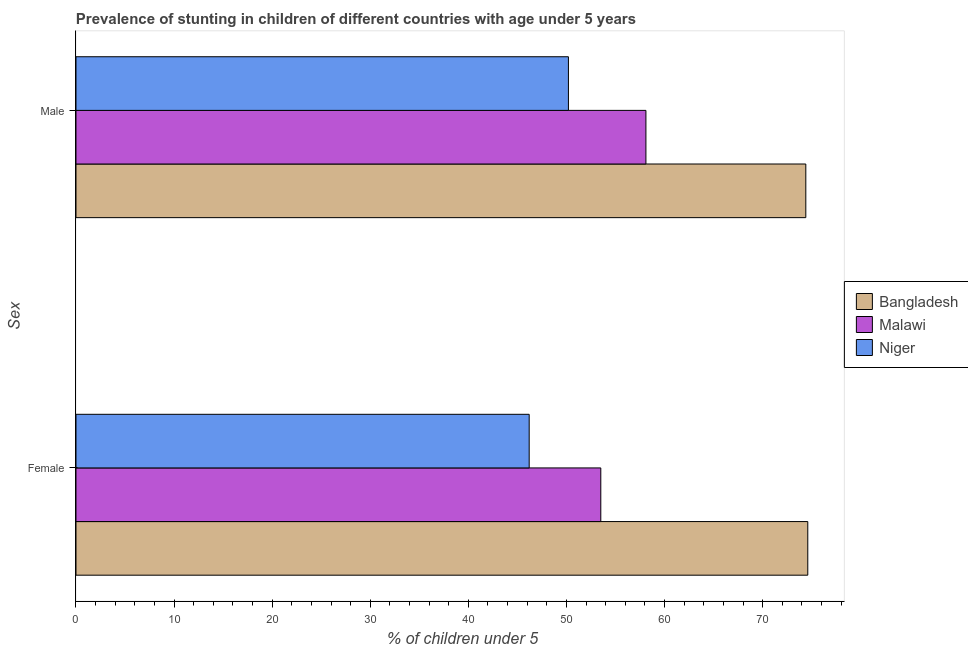How many groups of bars are there?
Provide a short and direct response. 2. Are the number of bars on each tick of the Y-axis equal?
Offer a very short reply. Yes. How many bars are there on the 1st tick from the top?
Make the answer very short. 3. What is the percentage of stunted male children in Malawi?
Ensure brevity in your answer.  58.1. Across all countries, what is the maximum percentage of stunted female children?
Give a very brief answer. 74.6. Across all countries, what is the minimum percentage of stunted male children?
Your answer should be very brief. 50.2. In which country was the percentage of stunted female children maximum?
Ensure brevity in your answer.  Bangladesh. In which country was the percentage of stunted male children minimum?
Provide a succinct answer. Niger. What is the total percentage of stunted female children in the graph?
Your response must be concise. 174.3. What is the difference between the percentage of stunted female children in Niger and that in Malawi?
Give a very brief answer. -7.3. What is the difference between the percentage of stunted male children in Malawi and the percentage of stunted female children in Bangladesh?
Your response must be concise. -16.5. What is the average percentage of stunted female children per country?
Your response must be concise. 58.1. What is the difference between the percentage of stunted female children and percentage of stunted male children in Malawi?
Your answer should be compact. -4.6. What is the ratio of the percentage of stunted female children in Malawi to that in Bangladesh?
Give a very brief answer. 0.72. In how many countries, is the percentage of stunted female children greater than the average percentage of stunted female children taken over all countries?
Keep it short and to the point. 1. What does the 1st bar from the top in Male represents?
Offer a very short reply. Niger. What does the 3rd bar from the bottom in Male represents?
Ensure brevity in your answer.  Niger. How many bars are there?
Make the answer very short. 6. Are all the bars in the graph horizontal?
Provide a succinct answer. Yes. How many countries are there in the graph?
Give a very brief answer. 3. What is the difference between two consecutive major ticks on the X-axis?
Your response must be concise. 10. Are the values on the major ticks of X-axis written in scientific E-notation?
Offer a terse response. No. Does the graph contain any zero values?
Offer a terse response. No. Does the graph contain grids?
Provide a short and direct response. No. Where does the legend appear in the graph?
Keep it short and to the point. Center right. How many legend labels are there?
Your response must be concise. 3. How are the legend labels stacked?
Keep it short and to the point. Vertical. What is the title of the graph?
Give a very brief answer. Prevalence of stunting in children of different countries with age under 5 years. What is the label or title of the X-axis?
Offer a terse response.  % of children under 5. What is the label or title of the Y-axis?
Ensure brevity in your answer.  Sex. What is the  % of children under 5 in Bangladesh in Female?
Offer a terse response. 74.6. What is the  % of children under 5 of Malawi in Female?
Make the answer very short. 53.5. What is the  % of children under 5 of Niger in Female?
Offer a very short reply. 46.2. What is the  % of children under 5 in Bangladesh in Male?
Your response must be concise. 74.4. What is the  % of children under 5 of Malawi in Male?
Keep it short and to the point. 58.1. What is the  % of children under 5 in Niger in Male?
Make the answer very short. 50.2. Across all Sex, what is the maximum  % of children under 5 in Bangladesh?
Make the answer very short. 74.6. Across all Sex, what is the maximum  % of children under 5 in Malawi?
Ensure brevity in your answer.  58.1. Across all Sex, what is the maximum  % of children under 5 in Niger?
Your answer should be compact. 50.2. Across all Sex, what is the minimum  % of children under 5 of Bangladesh?
Provide a short and direct response. 74.4. Across all Sex, what is the minimum  % of children under 5 of Malawi?
Your answer should be compact. 53.5. Across all Sex, what is the minimum  % of children under 5 in Niger?
Give a very brief answer. 46.2. What is the total  % of children under 5 of Bangladesh in the graph?
Your answer should be compact. 149. What is the total  % of children under 5 in Malawi in the graph?
Keep it short and to the point. 111.6. What is the total  % of children under 5 in Niger in the graph?
Your answer should be very brief. 96.4. What is the difference between the  % of children under 5 of Bangladesh in Female and that in Male?
Your response must be concise. 0.2. What is the difference between the  % of children under 5 in Malawi in Female and that in Male?
Provide a short and direct response. -4.6. What is the difference between the  % of children under 5 of Bangladesh in Female and the  % of children under 5 of Malawi in Male?
Provide a succinct answer. 16.5. What is the difference between the  % of children under 5 of Bangladesh in Female and the  % of children under 5 of Niger in Male?
Offer a very short reply. 24.4. What is the average  % of children under 5 in Bangladesh per Sex?
Provide a succinct answer. 74.5. What is the average  % of children under 5 in Malawi per Sex?
Make the answer very short. 55.8. What is the average  % of children under 5 of Niger per Sex?
Give a very brief answer. 48.2. What is the difference between the  % of children under 5 of Bangladesh and  % of children under 5 of Malawi in Female?
Offer a very short reply. 21.1. What is the difference between the  % of children under 5 of Bangladesh and  % of children under 5 of Niger in Female?
Give a very brief answer. 28.4. What is the difference between the  % of children under 5 in Malawi and  % of children under 5 in Niger in Female?
Provide a short and direct response. 7.3. What is the difference between the  % of children under 5 of Bangladesh and  % of children under 5 of Malawi in Male?
Provide a succinct answer. 16.3. What is the difference between the  % of children under 5 of Bangladesh and  % of children under 5 of Niger in Male?
Give a very brief answer. 24.2. What is the ratio of the  % of children under 5 in Bangladesh in Female to that in Male?
Your response must be concise. 1. What is the ratio of the  % of children under 5 in Malawi in Female to that in Male?
Offer a very short reply. 0.92. What is the ratio of the  % of children under 5 in Niger in Female to that in Male?
Ensure brevity in your answer.  0.92. What is the difference between the highest and the second highest  % of children under 5 in Niger?
Offer a terse response. 4. What is the difference between the highest and the lowest  % of children under 5 of Malawi?
Provide a short and direct response. 4.6. What is the difference between the highest and the lowest  % of children under 5 of Niger?
Your response must be concise. 4. 